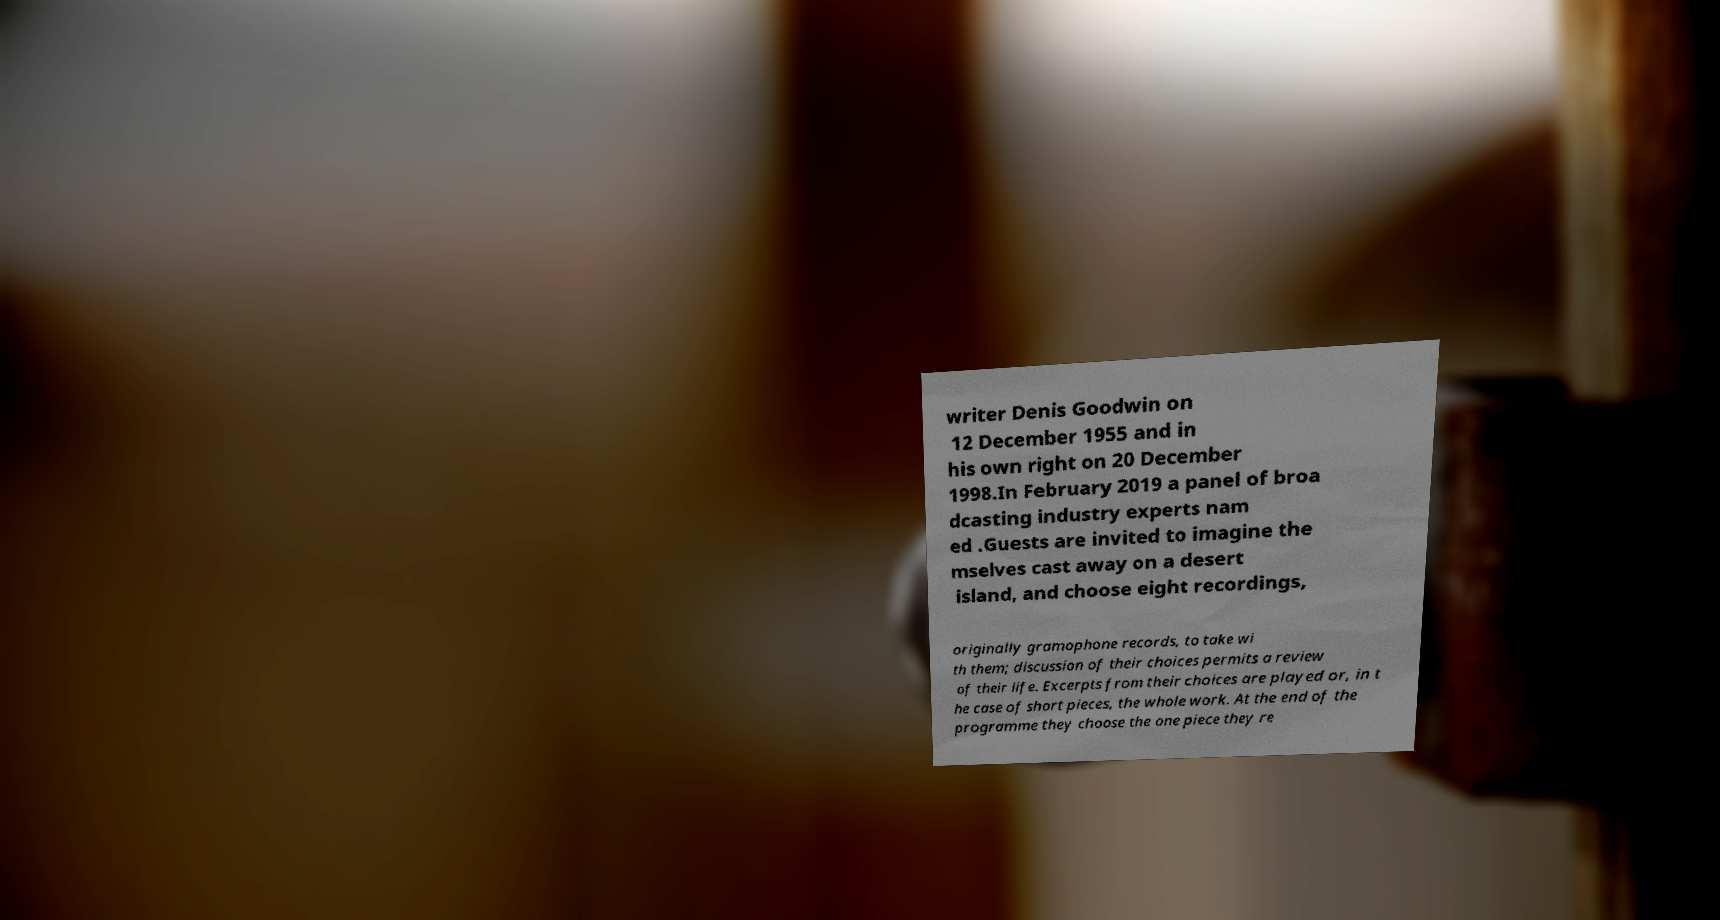For documentation purposes, I need the text within this image transcribed. Could you provide that? writer Denis Goodwin on 12 December 1955 and in his own right on 20 December 1998.In February 2019 a panel of broa dcasting industry experts nam ed .Guests are invited to imagine the mselves cast away on a desert island, and choose eight recordings, originally gramophone records, to take wi th them; discussion of their choices permits a review of their life. Excerpts from their choices are played or, in t he case of short pieces, the whole work. At the end of the programme they choose the one piece they re 